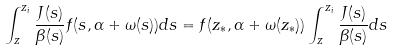<formula> <loc_0><loc_0><loc_500><loc_500>\int _ { z } ^ { z _ { i } } \frac { J ( s ) } { \beta ( s ) } f ( s , \alpha + \omega ( s ) ) d s = f ( z _ { * } , \alpha + \omega ( z _ { * } ) ) \int _ { z } ^ { z _ { i } } \frac { J ( s ) } { \beta ( s ) } d s</formula> 